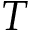Convert formula to latex. <formula><loc_0><loc_0><loc_500><loc_500>T</formula> 